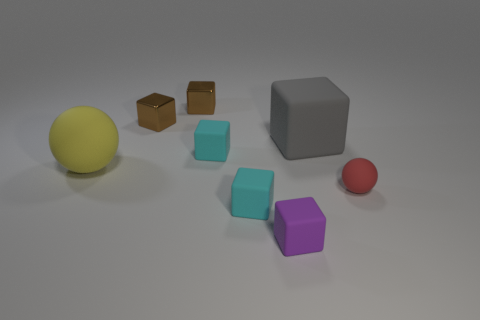Subtract all large blocks. How many blocks are left? 5 Subtract all gray cylinders. How many cyan blocks are left? 2 Subtract all gray blocks. How many blocks are left? 5 Subtract all spheres. How many objects are left? 6 Add 1 red matte things. How many red matte things exist? 2 Add 1 matte blocks. How many objects exist? 9 Subtract 0 gray cylinders. How many objects are left? 8 Subtract all green cubes. Subtract all green cylinders. How many cubes are left? 6 Subtract all tiny purple rubber things. Subtract all big matte things. How many objects are left? 5 Add 7 big balls. How many big balls are left? 8 